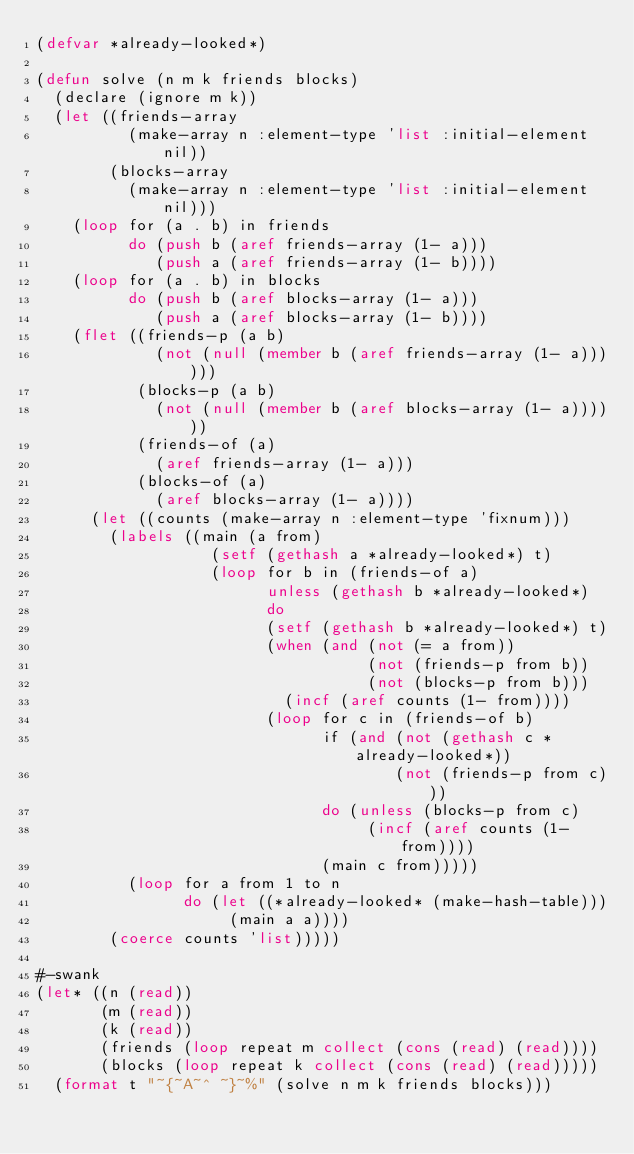Convert code to text. <code><loc_0><loc_0><loc_500><loc_500><_Lisp_>(defvar *already-looked*)

(defun solve (n m k friends blocks)
  (declare (ignore m k))
  (let ((friends-array
          (make-array n :element-type 'list :initial-element nil))
        (blocks-array
          (make-array n :element-type 'list :initial-element nil)))
    (loop for (a . b) in friends
          do (push b (aref friends-array (1- a)))
             (push a (aref friends-array (1- b))))
    (loop for (a . b) in blocks
          do (push b (aref blocks-array (1- a)))
             (push a (aref blocks-array (1- b))))
    (flet ((friends-p (a b)
             (not (null (member b (aref friends-array (1- a))))))
           (blocks-p (a b)
             (not (null (member b (aref blocks-array (1- a))))))
           (friends-of (a)
             (aref friends-array (1- a)))
           (blocks-of (a)
             (aref blocks-array (1- a))))
      (let ((counts (make-array n :element-type 'fixnum)))
        (labels ((main (a from)
                   (setf (gethash a *already-looked*) t)
                   (loop for b in (friends-of a)
                         unless (gethash b *already-looked*)
                         do
                         (setf (gethash b *already-looked*) t)
                         (when (and (not (= a from))
                                    (not (friends-p from b))
                                    (not (blocks-p from b)))
                           (incf (aref counts (1- from))))
                         (loop for c in (friends-of b)
                               if (and (not (gethash c *already-looked*))
                                       (not (friends-p from c)))
                               do (unless (blocks-p from c)
                                    (incf (aref counts (1- from))))
                               (main c from)))))
          (loop for a from 1 to n
                do (let ((*already-looked* (make-hash-table)))
                     (main a a))))
        (coerce counts 'list)))))

#-swank
(let* ((n (read))
       (m (read))
       (k (read))
       (friends (loop repeat m collect (cons (read) (read))))
       (blocks (loop repeat k collect (cons (read) (read)))))
  (format t "~{~A~^ ~}~%" (solve n m k friends blocks)))
</code> 